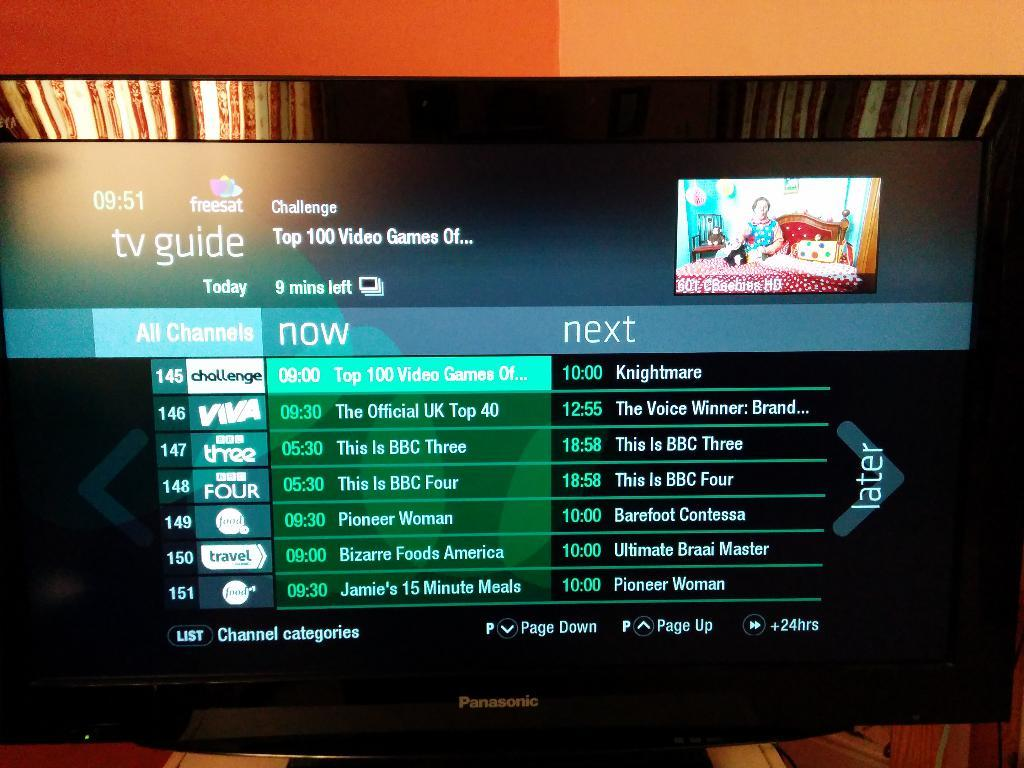What electronic device is present in the image? There is a TV in the image. What is displayed on the TV? There are texts and an image on the TV. Can you describe the image on the right side of the TV? The image contains a person on a bed. What type of crook can be seen in the image? There is no crook present in the image; it features a TV with texts and an image of a person on a bed. How many mouths are visible in the image? There are no mouths visible in the image; it only shows a TV with texts and an image of a person on a bed. 